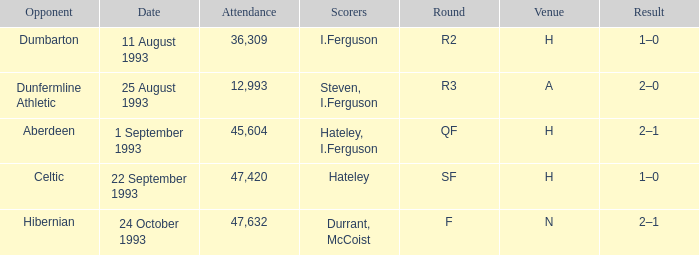What result is found for the round that has f? 2–1. 